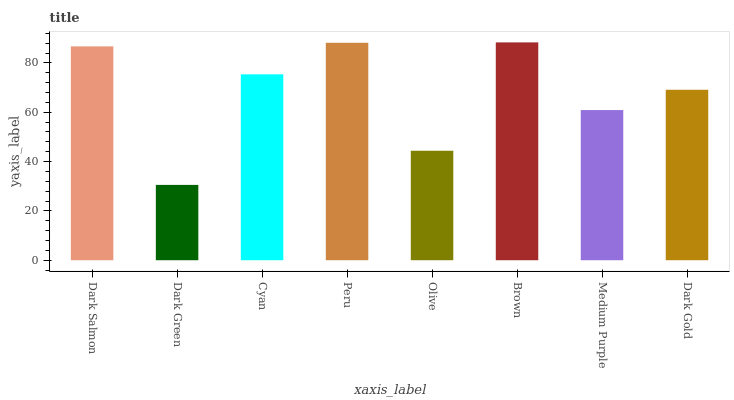Is Cyan the minimum?
Answer yes or no. No. Is Cyan the maximum?
Answer yes or no. No. Is Cyan greater than Dark Green?
Answer yes or no. Yes. Is Dark Green less than Cyan?
Answer yes or no. Yes. Is Dark Green greater than Cyan?
Answer yes or no. No. Is Cyan less than Dark Green?
Answer yes or no. No. Is Cyan the high median?
Answer yes or no. Yes. Is Dark Gold the low median?
Answer yes or no. Yes. Is Dark Green the high median?
Answer yes or no. No. Is Dark Salmon the low median?
Answer yes or no. No. 